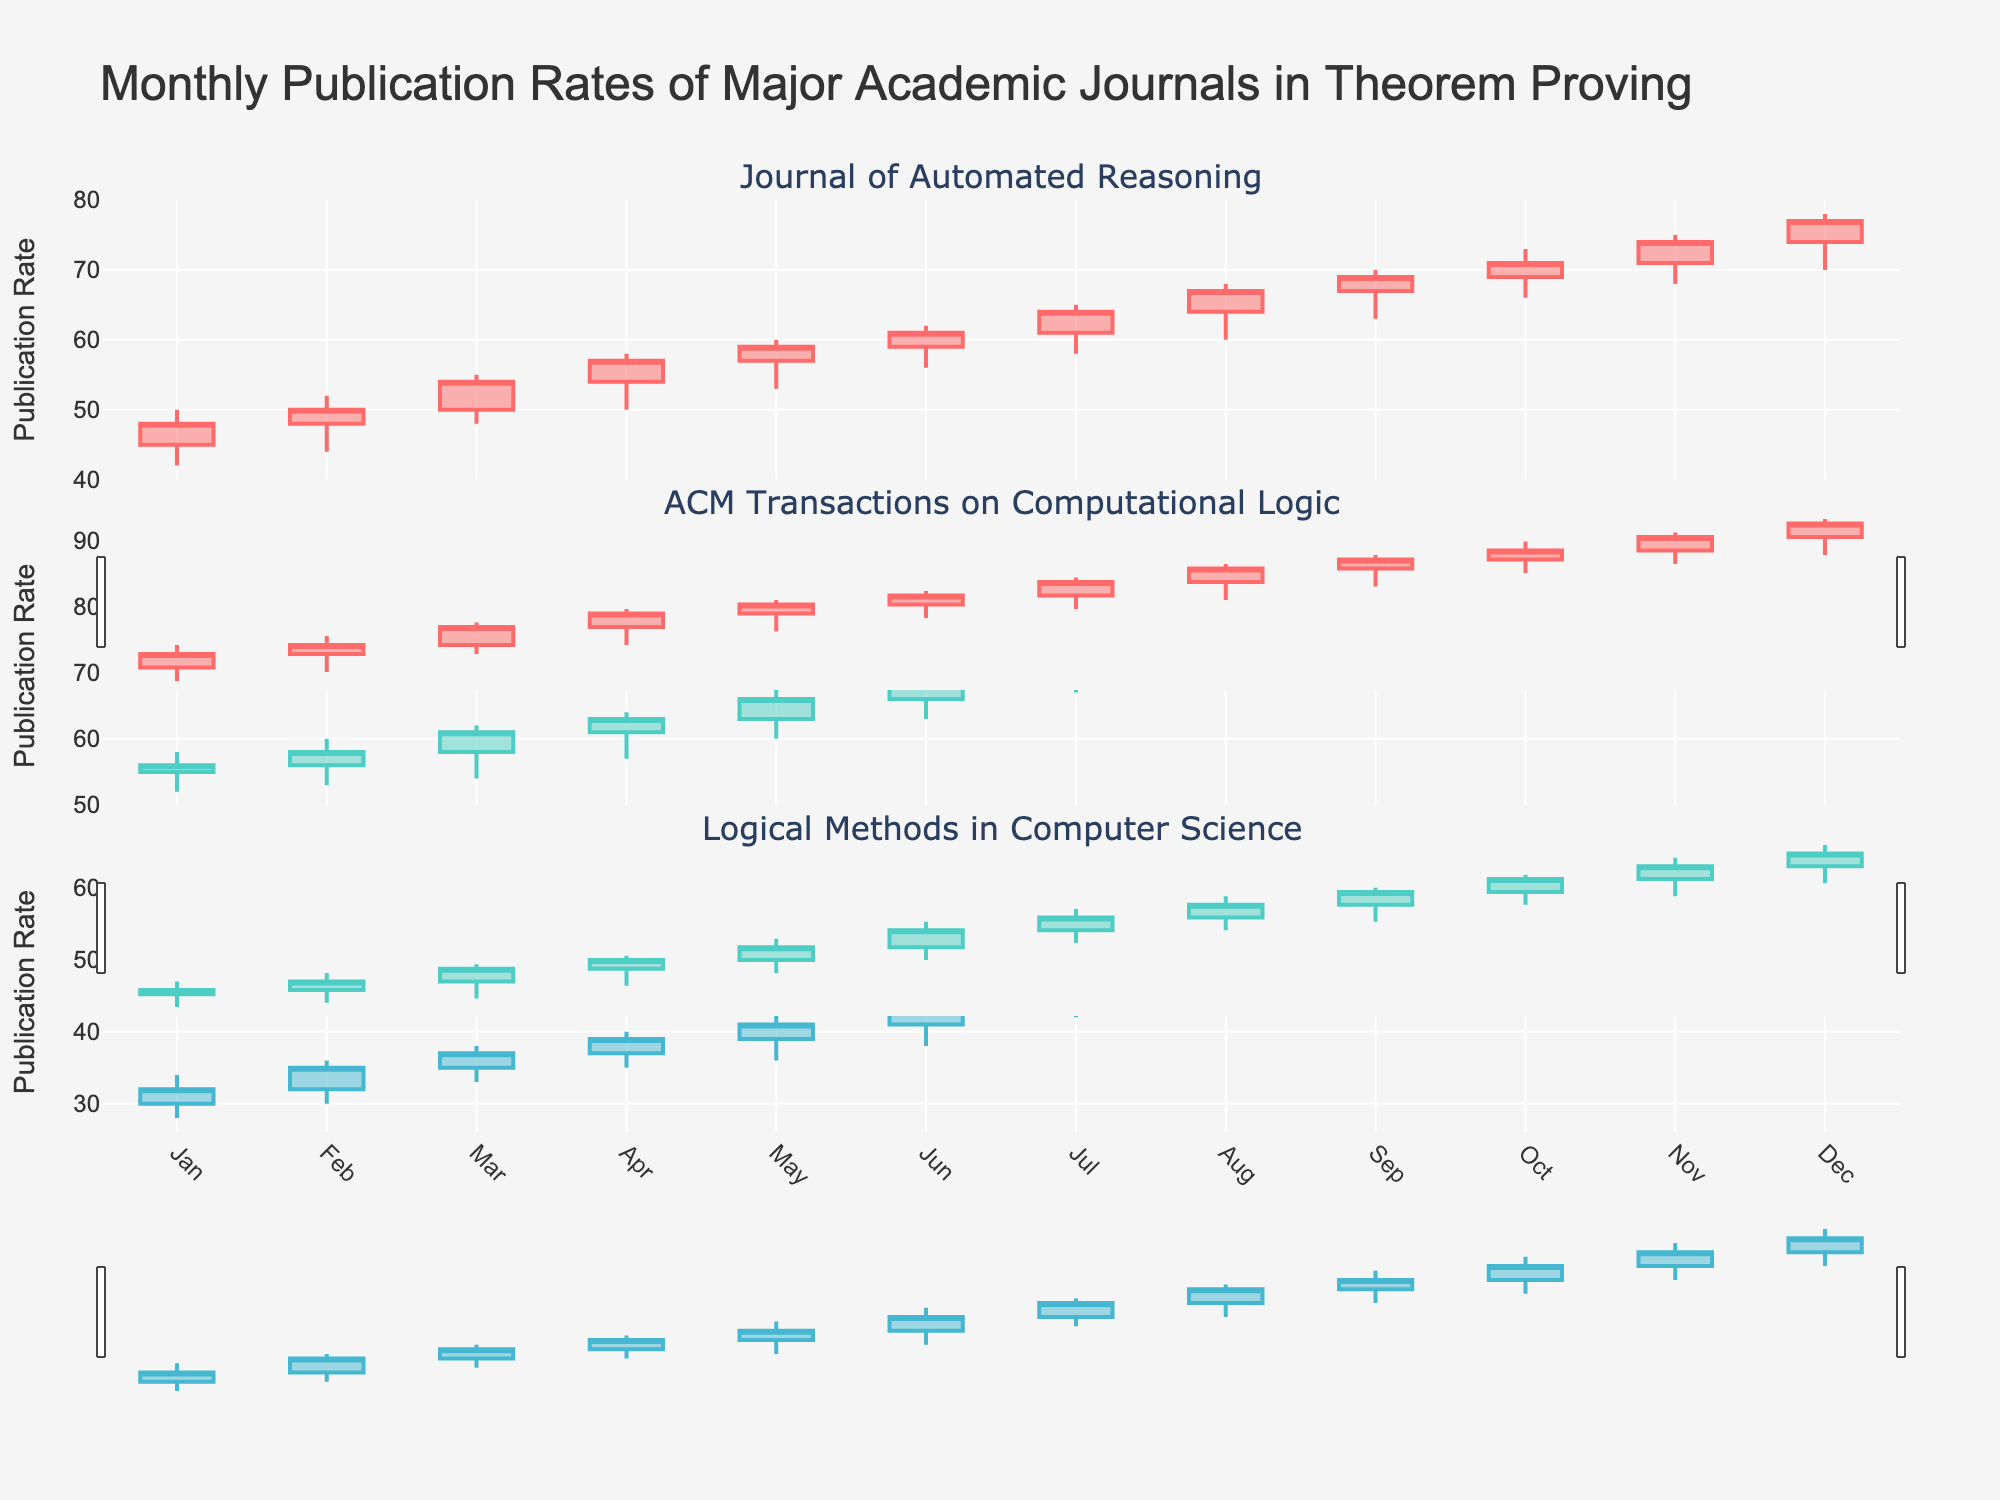Which journal has the highest publication rate in December? To find this, look at the "Close" price for December in each subplot’s candlestick. Compare the December "Close" prices.
Answer: ACM Transactions on Computational Logic What is the range of publication rates for Journal of Automated Reasoning in June? The range is the difference between the highest and lowest publication rates for June. Look at the "High" and "Low" values for Journal of Automated Reasoning in June's candlestick.
Answer: 62 - 56 = 6 Between ACM Transactions on Computational Logic and Logical Methods in Computer Science, which journal had a higher peak publication rate in August? Compare the "High" values for August in the candlesticks for both journals. Look at ACM Transactions on Computational Logic and Logical Methods in Computer Science for August.
Answer: ACM Transactions on Computational Logic What is the average closing publication rate for Logical Methods in Computer Science from January to March? Sum the "Close" values for January, February, and March, then divide by 3. (32 + 35 + 37) / 3
Answer: 34.67 Did Journal of Automated Reasoning experience an increase or decrease in its publication rate from January to December? Compare the "Close" values from January and December for Journal of Automated Reasoning. January's "Close" is 48, and December's "Close" is 77.
Answer: Increase Which month saw the lowest publication rate for Logical Methods in Computer Science? Find the lowest "Low" value in Logical Methods in Computer Science’s candlesticks, then identify the corresponding month.
Answer: January How many months saw Logical Methods in Computer Science's publication rate close above 50? Count the number of candlesticks where the "Close" value is above 50.
Answer: 7 months What is the combined highest publication rate in October for all journals? Sum the "High" values for each journal in October. Journal of Automated Reasoning: 73, ACM Transactions on Computational Logic: 83, Logical Methods in Computer Science: 57.
Answer: 213 Which journal had the smallest range of publication rates in any given month? Find the month with the smallest difference between the "High" and "Low" values for each journal. Compare these differences across all journals.
Answer: Logical Methods in Computer Science in January What was the general trend in publication rates for ACM Transactions on Computational Logic over the year? Look at the "Close" values from January to December in the candlesticks for ACM Transactions on Computational Logic. Observe whether these values generally increase, decrease, or stay stable.
Answer: Increasing 